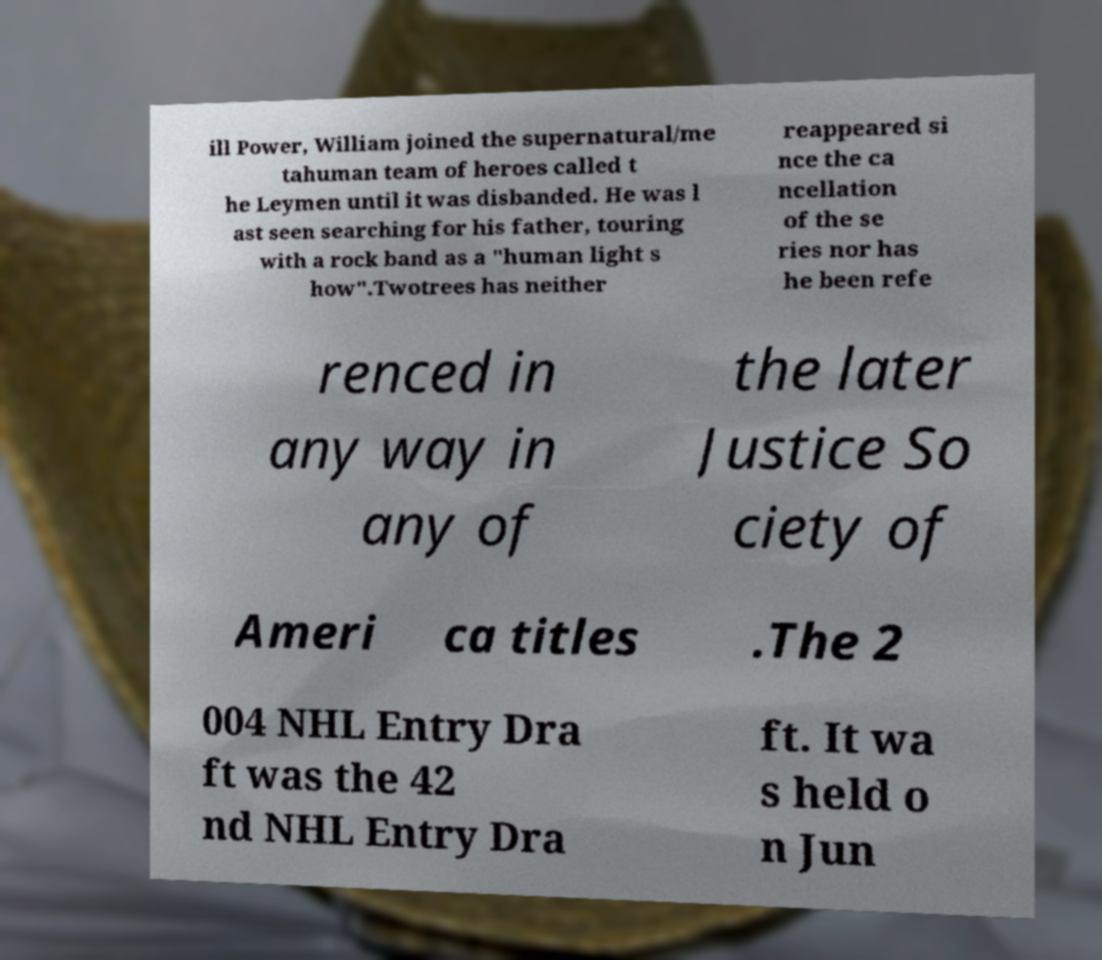Please read and relay the text visible in this image. What does it say? ill Power, William joined the supernatural/me tahuman team of heroes called t he Leymen until it was disbanded. He was l ast seen searching for his father, touring with a rock band as a "human light s how".Twotrees has neither reappeared si nce the ca ncellation of the se ries nor has he been refe renced in any way in any of the later Justice So ciety of Ameri ca titles .The 2 004 NHL Entry Dra ft was the 42 nd NHL Entry Dra ft. It wa s held o n Jun 